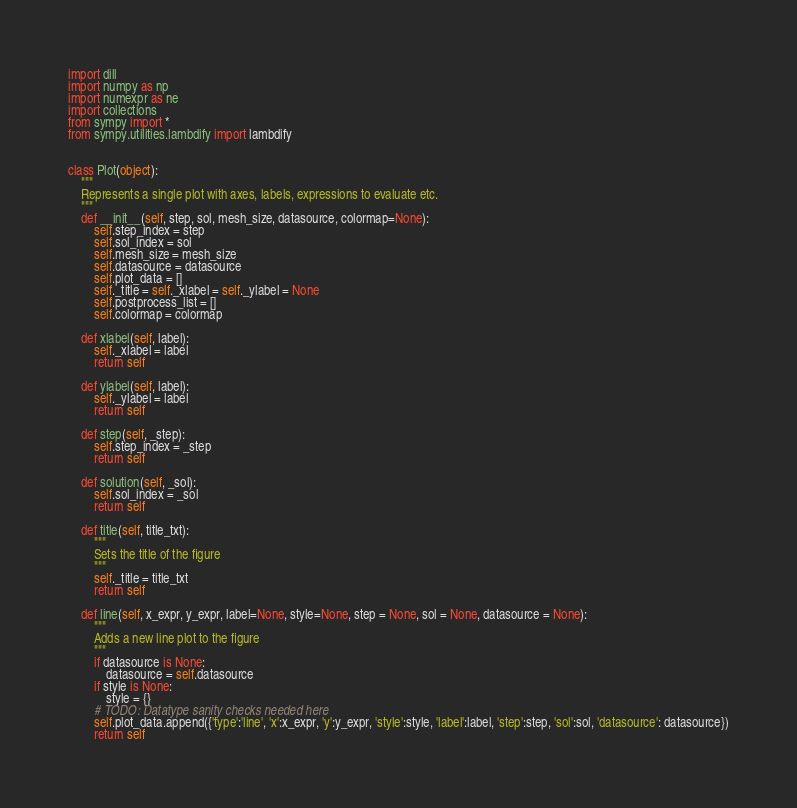<code> <loc_0><loc_0><loc_500><loc_500><_Python_>import dill
import numpy as np
import numexpr as ne
import collections
from sympy import *
from sympy.utilities.lambdify import lambdify


class Plot(object):
    """
    Represents a single plot with axes, labels, expressions to evaluate etc.
    """
    def __init__(self, step, sol, mesh_size, datasource, colormap=None):
        self.step_index = step
        self.sol_index = sol
        self.mesh_size = mesh_size
        self.datasource = datasource
        self.plot_data = []
        self._title = self._xlabel = self._ylabel = None
        self.postprocess_list = []
        self.colormap = colormap

    def xlabel(self, label):
        self._xlabel = label
        return self

    def ylabel(self, label):
        self._ylabel = label
        return self

    def step(self, _step):
        self.step_index = _step
        return self

    def solution(self, _sol):
        self.sol_index = _sol
        return self

    def title(self, title_txt):
        """
        Sets the title of the figure
        """
        self._title = title_txt
        return self

    def line(self, x_expr, y_expr, label=None, style=None, step = None, sol = None, datasource = None):
        """
        Adds a new line plot to the figure
        """
        if datasource is None:
            datasource = self.datasource
        if style is None:
            style = {}
        # TODO: Datatype sanity checks needed here
        self.plot_data.append({'type':'line', 'x':x_expr, 'y':y_expr, 'style':style, 'label':label, 'step':step, 'sol':sol, 'datasource': datasource})
        return self
</code> 